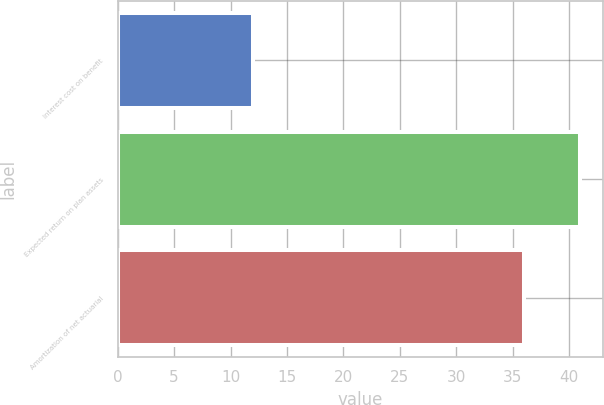<chart> <loc_0><loc_0><loc_500><loc_500><bar_chart><fcel>Interest cost on benefit<fcel>Expected return on plan assets<fcel>Amortization of net actuarial<nl><fcel>12<fcel>41<fcel>36<nl></chart> 